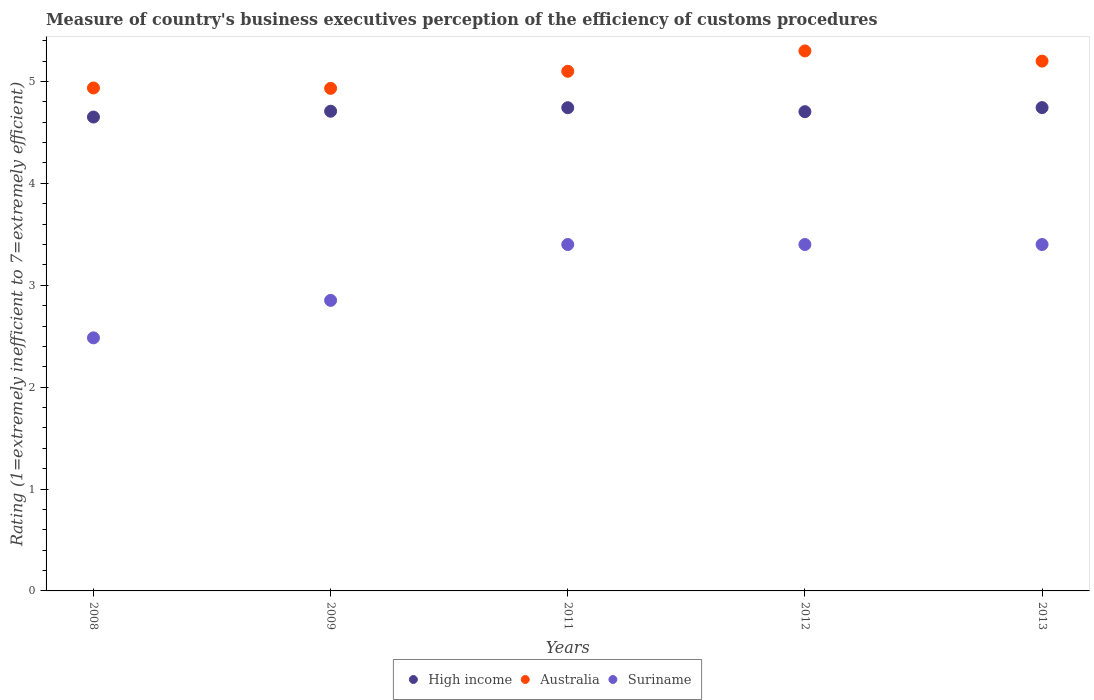What is the rating of the efficiency of customs procedure in High income in 2011?
Provide a succinct answer. 4.74. Across all years, what is the maximum rating of the efficiency of customs procedure in Suriname?
Your answer should be compact. 3.4. Across all years, what is the minimum rating of the efficiency of customs procedure in Australia?
Provide a short and direct response. 4.93. In which year was the rating of the efficiency of customs procedure in Suriname maximum?
Offer a very short reply. 2011. What is the total rating of the efficiency of customs procedure in High income in the graph?
Offer a terse response. 23.55. What is the difference between the rating of the efficiency of customs procedure in Australia in 2009 and that in 2012?
Provide a succinct answer. -0.37. What is the difference between the rating of the efficiency of customs procedure in Suriname in 2013 and the rating of the efficiency of customs procedure in High income in 2009?
Keep it short and to the point. -1.31. What is the average rating of the efficiency of customs procedure in High income per year?
Provide a short and direct response. 4.71. In the year 2012, what is the difference between the rating of the efficiency of customs procedure in High income and rating of the efficiency of customs procedure in Suriname?
Your response must be concise. 1.3. What is the ratio of the rating of the efficiency of customs procedure in Australia in 2009 to that in 2012?
Your answer should be compact. 0.93. Is the rating of the efficiency of customs procedure in Suriname in 2008 less than that in 2012?
Offer a very short reply. Yes. What is the difference between the highest and the lowest rating of the efficiency of customs procedure in Australia?
Your answer should be very brief. 0.37. In how many years, is the rating of the efficiency of customs procedure in Australia greater than the average rating of the efficiency of customs procedure in Australia taken over all years?
Ensure brevity in your answer.  3. Does the rating of the efficiency of customs procedure in Suriname monotonically increase over the years?
Offer a very short reply. No. Is the rating of the efficiency of customs procedure in High income strictly greater than the rating of the efficiency of customs procedure in Suriname over the years?
Your answer should be very brief. Yes. How many dotlines are there?
Offer a very short reply. 3. Does the graph contain any zero values?
Offer a terse response. No. How are the legend labels stacked?
Make the answer very short. Horizontal. What is the title of the graph?
Your answer should be very brief. Measure of country's business executives perception of the efficiency of customs procedures. Does "Cabo Verde" appear as one of the legend labels in the graph?
Offer a terse response. No. What is the label or title of the Y-axis?
Ensure brevity in your answer.  Rating (1=extremely inefficient to 7=extremely efficient). What is the Rating (1=extremely inefficient to 7=extremely efficient) in High income in 2008?
Your response must be concise. 4.65. What is the Rating (1=extremely inefficient to 7=extremely efficient) of Australia in 2008?
Give a very brief answer. 4.94. What is the Rating (1=extremely inefficient to 7=extremely efficient) of Suriname in 2008?
Offer a terse response. 2.48. What is the Rating (1=extremely inefficient to 7=extremely efficient) of High income in 2009?
Your answer should be compact. 4.71. What is the Rating (1=extremely inefficient to 7=extremely efficient) in Australia in 2009?
Make the answer very short. 4.93. What is the Rating (1=extremely inefficient to 7=extremely efficient) in Suriname in 2009?
Ensure brevity in your answer.  2.85. What is the Rating (1=extremely inefficient to 7=extremely efficient) in High income in 2011?
Your response must be concise. 4.74. What is the Rating (1=extremely inefficient to 7=extremely efficient) of High income in 2012?
Your answer should be very brief. 4.7. What is the Rating (1=extremely inefficient to 7=extremely efficient) in Suriname in 2012?
Your answer should be compact. 3.4. What is the Rating (1=extremely inefficient to 7=extremely efficient) of High income in 2013?
Offer a terse response. 4.74. Across all years, what is the maximum Rating (1=extremely inefficient to 7=extremely efficient) in High income?
Provide a short and direct response. 4.74. Across all years, what is the maximum Rating (1=extremely inefficient to 7=extremely efficient) in Australia?
Give a very brief answer. 5.3. Across all years, what is the minimum Rating (1=extremely inefficient to 7=extremely efficient) of High income?
Your response must be concise. 4.65. Across all years, what is the minimum Rating (1=extremely inefficient to 7=extremely efficient) in Australia?
Your response must be concise. 4.93. Across all years, what is the minimum Rating (1=extremely inefficient to 7=extremely efficient) of Suriname?
Provide a succinct answer. 2.48. What is the total Rating (1=extremely inefficient to 7=extremely efficient) of High income in the graph?
Give a very brief answer. 23.55. What is the total Rating (1=extremely inefficient to 7=extremely efficient) in Australia in the graph?
Offer a very short reply. 25.47. What is the total Rating (1=extremely inefficient to 7=extremely efficient) of Suriname in the graph?
Give a very brief answer. 15.54. What is the difference between the Rating (1=extremely inefficient to 7=extremely efficient) of High income in 2008 and that in 2009?
Provide a short and direct response. -0.06. What is the difference between the Rating (1=extremely inefficient to 7=extremely efficient) of Australia in 2008 and that in 2009?
Your answer should be compact. 0. What is the difference between the Rating (1=extremely inefficient to 7=extremely efficient) of Suriname in 2008 and that in 2009?
Your answer should be very brief. -0.37. What is the difference between the Rating (1=extremely inefficient to 7=extremely efficient) in High income in 2008 and that in 2011?
Make the answer very short. -0.09. What is the difference between the Rating (1=extremely inefficient to 7=extremely efficient) of Australia in 2008 and that in 2011?
Keep it short and to the point. -0.16. What is the difference between the Rating (1=extremely inefficient to 7=extremely efficient) of Suriname in 2008 and that in 2011?
Your answer should be compact. -0.92. What is the difference between the Rating (1=extremely inefficient to 7=extremely efficient) in High income in 2008 and that in 2012?
Keep it short and to the point. -0.05. What is the difference between the Rating (1=extremely inefficient to 7=extremely efficient) of Australia in 2008 and that in 2012?
Your answer should be very brief. -0.36. What is the difference between the Rating (1=extremely inefficient to 7=extremely efficient) in Suriname in 2008 and that in 2012?
Provide a short and direct response. -0.92. What is the difference between the Rating (1=extremely inefficient to 7=extremely efficient) of High income in 2008 and that in 2013?
Your response must be concise. -0.09. What is the difference between the Rating (1=extremely inefficient to 7=extremely efficient) of Australia in 2008 and that in 2013?
Offer a terse response. -0.26. What is the difference between the Rating (1=extremely inefficient to 7=extremely efficient) of Suriname in 2008 and that in 2013?
Your answer should be very brief. -0.92. What is the difference between the Rating (1=extremely inefficient to 7=extremely efficient) in High income in 2009 and that in 2011?
Offer a very short reply. -0.03. What is the difference between the Rating (1=extremely inefficient to 7=extremely efficient) of Australia in 2009 and that in 2011?
Ensure brevity in your answer.  -0.17. What is the difference between the Rating (1=extremely inefficient to 7=extremely efficient) in Suriname in 2009 and that in 2011?
Your answer should be very brief. -0.55. What is the difference between the Rating (1=extremely inefficient to 7=extremely efficient) of High income in 2009 and that in 2012?
Your answer should be very brief. 0. What is the difference between the Rating (1=extremely inefficient to 7=extremely efficient) of Australia in 2009 and that in 2012?
Provide a succinct answer. -0.37. What is the difference between the Rating (1=extremely inefficient to 7=extremely efficient) in Suriname in 2009 and that in 2012?
Keep it short and to the point. -0.55. What is the difference between the Rating (1=extremely inefficient to 7=extremely efficient) of High income in 2009 and that in 2013?
Your answer should be compact. -0.04. What is the difference between the Rating (1=extremely inefficient to 7=extremely efficient) in Australia in 2009 and that in 2013?
Make the answer very short. -0.27. What is the difference between the Rating (1=extremely inefficient to 7=extremely efficient) of Suriname in 2009 and that in 2013?
Ensure brevity in your answer.  -0.55. What is the difference between the Rating (1=extremely inefficient to 7=extremely efficient) of High income in 2011 and that in 2012?
Your response must be concise. 0.04. What is the difference between the Rating (1=extremely inefficient to 7=extremely efficient) of High income in 2011 and that in 2013?
Give a very brief answer. -0. What is the difference between the Rating (1=extremely inefficient to 7=extremely efficient) of Australia in 2011 and that in 2013?
Your answer should be compact. -0.1. What is the difference between the Rating (1=extremely inefficient to 7=extremely efficient) of High income in 2012 and that in 2013?
Your response must be concise. -0.04. What is the difference between the Rating (1=extremely inefficient to 7=extremely efficient) of High income in 2008 and the Rating (1=extremely inefficient to 7=extremely efficient) of Australia in 2009?
Your response must be concise. -0.28. What is the difference between the Rating (1=extremely inefficient to 7=extremely efficient) in High income in 2008 and the Rating (1=extremely inefficient to 7=extremely efficient) in Suriname in 2009?
Make the answer very short. 1.8. What is the difference between the Rating (1=extremely inefficient to 7=extremely efficient) of Australia in 2008 and the Rating (1=extremely inefficient to 7=extremely efficient) of Suriname in 2009?
Your response must be concise. 2.08. What is the difference between the Rating (1=extremely inefficient to 7=extremely efficient) of High income in 2008 and the Rating (1=extremely inefficient to 7=extremely efficient) of Australia in 2011?
Your response must be concise. -0.45. What is the difference between the Rating (1=extremely inefficient to 7=extremely efficient) in High income in 2008 and the Rating (1=extremely inefficient to 7=extremely efficient) in Suriname in 2011?
Your answer should be compact. 1.25. What is the difference between the Rating (1=extremely inefficient to 7=extremely efficient) in Australia in 2008 and the Rating (1=extremely inefficient to 7=extremely efficient) in Suriname in 2011?
Make the answer very short. 1.54. What is the difference between the Rating (1=extremely inefficient to 7=extremely efficient) in High income in 2008 and the Rating (1=extremely inefficient to 7=extremely efficient) in Australia in 2012?
Make the answer very short. -0.65. What is the difference between the Rating (1=extremely inefficient to 7=extremely efficient) of High income in 2008 and the Rating (1=extremely inefficient to 7=extremely efficient) of Suriname in 2012?
Your response must be concise. 1.25. What is the difference between the Rating (1=extremely inefficient to 7=extremely efficient) in Australia in 2008 and the Rating (1=extremely inefficient to 7=extremely efficient) in Suriname in 2012?
Your answer should be very brief. 1.54. What is the difference between the Rating (1=extremely inefficient to 7=extremely efficient) in High income in 2008 and the Rating (1=extremely inefficient to 7=extremely efficient) in Australia in 2013?
Make the answer very short. -0.55. What is the difference between the Rating (1=extremely inefficient to 7=extremely efficient) of High income in 2008 and the Rating (1=extremely inefficient to 7=extremely efficient) of Suriname in 2013?
Keep it short and to the point. 1.25. What is the difference between the Rating (1=extremely inefficient to 7=extremely efficient) in Australia in 2008 and the Rating (1=extremely inefficient to 7=extremely efficient) in Suriname in 2013?
Keep it short and to the point. 1.54. What is the difference between the Rating (1=extremely inefficient to 7=extremely efficient) of High income in 2009 and the Rating (1=extremely inefficient to 7=extremely efficient) of Australia in 2011?
Make the answer very short. -0.39. What is the difference between the Rating (1=extremely inefficient to 7=extremely efficient) of High income in 2009 and the Rating (1=extremely inefficient to 7=extremely efficient) of Suriname in 2011?
Offer a very short reply. 1.31. What is the difference between the Rating (1=extremely inefficient to 7=extremely efficient) of Australia in 2009 and the Rating (1=extremely inefficient to 7=extremely efficient) of Suriname in 2011?
Make the answer very short. 1.53. What is the difference between the Rating (1=extremely inefficient to 7=extremely efficient) in High income in 2009 and the Rating (1=extremely inefficient to 7=extremely efficient) in Australia in 2012?
Your answer should be very brief. -0.59. What is the difference between the Rating (1=extremely inefficient to 7=extremely efficient) of High income in 2009 and the Rating (1=extremely inefficient to 7=extremely efficient) of Suriname in 2012?
Keep it short and to the point. 1.31. What is the difference between the Rating (1=extremely inefficient to 7=extremely efficient) of Australia in 2009 and the Rating (1=extremely inefficient to 7=extremely efficient) of Suriname in 2012?
Ensure brevity in your answer.  1.53. What is the difference between the Rating (1=extremely inefficient to 7=extremely efficient) of High income in 2009 and the Rating (1=extremely inefficient to 7=extremely efficient) of Australia in 2013?
Offer a very short reply. -0.49. What is the difference between the Rating (1=extremely inefficient to 7=extremely efficient) of High income in 2009 and the Rating (1=extremely inefficient to 7=extremely efficient) of Suriname in 2013?
Give a very brief answer. 1.31. What is the difference between the Rating (1=extremely inefficient to 7=extremely efficient) of Australia in 2009 and the Rating (1=extremely inefficient to 7=extremely efficient) of Suriname in 2013?
Make the answer very short. 1.53. What is the difference between the Rating (1=extremely inefficient to 7=extremely efficient) of High income in 2011 and the Rating (1=extremely inefficient to 7=extremely efficient) of Australia in 2012?
Ensure brevity in your answer.  -0.56. What is the difference between the Rating (1=extremely inefficient to 7=extremely efficient) of High income in 2011 and the Rating (1=extremely inefficient to 7=extremely efficient) of Suriname in 2012?
Ensure brevity in your answer.  1.34. What is the difference between the Rating (1=extremely inefficient to 7=extremely efficient) of High income in 2011 and the Rating (1=extremely inefficient to 7=extremely efficient) of Australia in 2013?
Make the answer very short. -0.46. What is the difference between the Rating (1=extremely inefficient to 7=extremely efficient) in High income in 2011 and the Rating (1=extremely inefficient to 7=extremely efficient) in Suriname in 2013?
Keep it short and to the point. 1.34. What is the difference between the Rating (1=extremely inefficient to 7=extremely efficient) in Australia in 2011 and the Rating (1=extremely inefficient to 7=extremely efficient) in Suriname in 2013?
Offer a terse response. 1.7. What is the difference between the Rating (1=extremely inefficient to 7=extremely efficient) of High income in 2012 and the Rating (1=extremely inefficient to 7=extremely efficient) of Australia in 2013?
Provide a succinct answer. -0.5. What is the difference between the Rating (1=extremely inefficient to 7=extremely efficient) of High income in 2012 and the Rating (1=extremely inefficient to 7=extremely efficient) of Suriname in 2013?
Your response must be concise. 1.3. What is the difference between the Rating (1=extremely inefficient to 7=extremely efficient) of Australia in 2012 and the Rating (1=extremely inefficient to 7=extremely efficient) of Suriname in 2013?
Your answer should be compact. 1.9. What is the average Rating (1=extremely inefficient to 7=extremely efficient) in High income per year?
Provide a succinct answer. 4.71. What is the average Rating (1=extremely inefficient to 7=extremely efficient) of Australia per year?
Give a very brief answer. 5.09. What is the average Rating (1=extremely inefficient to 7=extremely efficient) of Suriname per year?
Your response must be concise. 3.11. In the year 2008, what is the difference between the Rating (1=extremely inefficient to 7=extremely efficient) in High income and Rating (1=extremely inefficient to 7=extremely efficient) in Australia?
Ensure brevity in your answer.  -0.29. In the year 2008, what is the difference between the Rating (1=extremely inefficient to 7=extremely efficient) in High income and Rating (1=extremely inefficient to 7=extremely efficient) in Suriname?
Make the answer very short. 2.17. In the year 2008, what is the difference between the Rating (1=extremely inefficient to 7=extremely efficient) in Australia and Rating (1=extremely inefficient to 7=extremely efficient) in Suriname?
Keep it short and to the point. 2.45. In the year 2009, what is the difference between the Rating (1=extremely inefficient to 7=extremely efficient) of High income and Rating (1=extremely inefficient to 7=extremely efficient) of Australia?
Ensure brevity in your answer.  -0.22. In the year 2009, what is the difference between the Rating (1=extremely inefficient to 7=extremely efficient) in High income and Rating (1=extremely inefficient to 7=extremely efficient) in Suriname?
Your response must be concise. 1.86. In the year 2009, what is the difference between the Rating (1=extremely inefficient to 7=extremely efficient) of Australia and Rating (1=extremely inefficient to 7=extremely efficient) of Suriname?
Keep it short and to the point. 2.08. In the year 2011, what is the difference between the Rating (1=extremely inefficient to 7=extremely efficient) in High income and Rating (1=extremely inefficient to 7=extremely efficient) in Australia?
Your answer should be compact. -0.36. In the year 2011, what is the difference between the Rating (1=extremely inefficient to 7=extremely efficient) of High income and Rating (1=extremely inefficient to 7=extremely efficient) of Suriname?
Your answer should be very brief. 1.34. In the year 2012, what is the difference between the Rating (1=extremely inefficient to 7=extremely efficient) of High income and Rating (1=extremely inefficient to 7=extremely efficient) of Australia?
Your answer should be very brief. -0.6. In the year 2012, what is the difference between the Rating (1=extremely inefficient to 7=extremely efficient) in High income and Rating (1=extremely inefficient to 7=extremely efficient) in Suriname?
Make the answer very short. 1.3. In the year 2012, what is the difference between the Rating (1=extremely inefficient to 7=extremely efficient) of Australia and Rating (1=extremely inefficient to 7=extremely efficient) of Suriname?
Make the answer very short. 1.9. In the year 2013, what is the difference between the Rating (1=extremely inefficient to 7=extremely efficient) of High income and Rating (1=extremely inefficient to 7=extremely efficient) of Australia?
Offer a terse response. -0.46. In the year 2013, what is the difference between the Rating (1=extremely inefficient to 7=extremely efficient) in High income and Rating (1=extremely inefficient to 7=extremely efficient) in Suriname?
Keep it short and to the point. 1.34. What is the ratio of the Rating (1=extremely inefficient to 7=extremely efficient) of High income in 2008 to that in 2009?
Keep it short and to the point. 0.99. What is the ratio of the Rating (1=extremely inefficient to 7=extremely efficient) in Australia in 2008 to that in 2009?
Ensure brevity in your answer.  1. What is the ratio of the Rating (1=extremely inefficient to 7=extremely efficient) in Suriname in 2008 to that in 2009?
Give a very brief answer. 0.87. What is the ratio of the Rating (1=extremely inefficient to 7=extremely efficient) of High income in 2008 to that in 2011?
Give a very brief answer. 0.98. What is the ratio of the Rating (1=extremely inefficient to 7=extremely efficient) in Australia in 2008 to that in 2011?
Your answer should be very brief. 0.97. What is the ratio of the Rating (1=extremely inefficient to 7=extremely efficient) of Suriname in 2008 to that in 2011?
Your response must be concise. 0.73. What is the ratio of the Rating (1=extremely inefficient to 7=extremely efficient) of High income in 2008 to that in 2012?
Provide a succinct answer. 0.99. What is the ratio of the Rating (1=extremely inefficient to 7=extremely efficient) of Australia in 2008 to that in 2012?
Offer a terse response. 0.93. What is the ratio of the Rating (1=extremely inefficient to 7=extremely efficient) in Suriname in 2008 to that in 2012?
Make the answer very short. 0.73. What is the ratio of the Rating (1=extremely inefficient to 7=extremely efficient) of High income in 2008 to that in 2013?
Your answer should be very brief. 0.98. What is the ratio of the Rating (1=extremely inefficient to 7=extremely efficient) of Australia in 2008 to that in 2013?
Your answer should be compact. 0.95. What is the ratio of the Rating (1=extremely inefficient to 7=extremely efficient) of Suriname in 2008 to that in 2013?
Your answer should be compact. 0.73. What is the ratio of the Rating (1=extremely inefficient to 7=extremely efficient) in High income in 2009 to that in 2011?
Offer a very short reply. 0.99. What is the ratio of the Rating (1=extremely inefficient to 7=extremely efficient) in Australia in 2009 to that in 2011?
Your answer should be compact. 0.97. What is the ratio of the Rating (1=extremely inefficient to 7=extremely efficient) in Suriname in 2009 to that in 2011?
Provide a short and direct response. 0.84. What is the ratio of the Rating (1=extremely inefficient to 7=extremely efficient) of Australia in 2009 to that in 2012?
Offer a terse response. 0.93. What is the ratio of the Rating (1=extremely inefficient to 7=extremely efficient) in Suriname in 2009 to that in 2012?
Your answer should be very brief. 0.84. What is the ratio of the Rating (1=extremely inefficient to 7=extremely efficient) of High income in 2009 to that in 2013?
Your response must be concise. 0.99. What is the ratio of the Rating (1=extremely inefficient to 7=extremely efficient) of Australia in 2009 to that in 2013?
Make the answer very short. 0.95. What is the ratio of the Rating (1=extremely inefficient to 7=extremely efficient) of Suriname in 2009 to that in 2013?
Offer a very short reply. 0.84. What is the ratio of the Rating (1=extremely inefficient to 7=extremely efficient) in High income in 2011 to that in 2012?
Provide a short and direct response. 1.01. What is the ratio of the Rating (1=extremely inefficient to 7=extremely efficient) of Australia in 2011 to that in 2012?
Offer a terse response. 0.96. What is the ratio of the Rating (1=extremely inefficient to 7=extremely efficient) in Suriname in 2011 to that in 2012?
Offer a very short reply. 1. What is the ratio of the Rating (1=extremely inefficient to 7=extremely efficient) in High income in 2011 to that in 2013?
Offer a very short reply. 1. What is the ratio of the Rating (1=extremely inefficient to 7=extremely efficient) in Australia in 2011 to that in 2013?
Your response must be concise. 0.98. What is the ratio of the Rating (1=extremely inefficient to 7=extremely efficient) of High income in 2012 to that in 2013?
Offer a terse response. 0.99. What is the ratio of the Rating (1=extremely inefficient to 7=extremely efficient) in Australia in 2012 to that in 2013?
Provide a succinct answer. 1.02. What is the ratio of the Rating (1=extremely inefficient to 7=extremely efficient) of Suriname in 2012 to that in 2013?
Ensure brevity in your answer.  1. What is the difference between the highest and the second highest Rating (1=extremely inefficient to 7=extremely efficient) in High income?
Provide a succinct answer. 0. What is the difference between the highest and the lowest Rating (1=extremely inefficient to 7=extremely efficient) of High income?
Your response must be concise. 0.09. What is the difference between the highest and the lowest Rating (1=extremely inefficient to 7=extremely efficient) in Australia?
Keep it short and to the point. 0.37. What is the difference between the highest and the lowest Rating (1=extremely inefficient to 7=extremely efficient) of Suriname?
Ensure brevity in your answer.  0.92. 